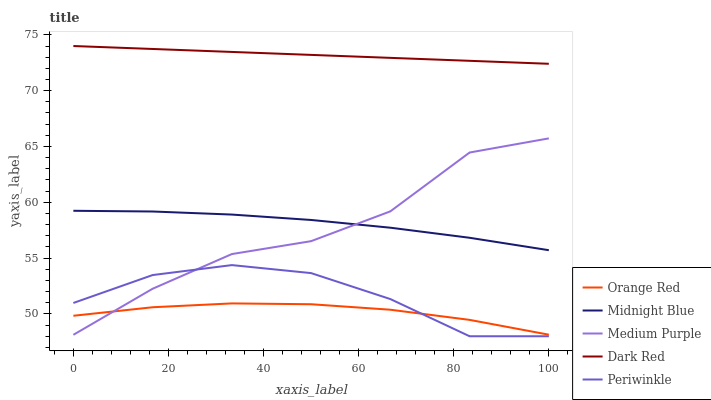Does Periwinkle have the minimum area under the curve?
Answer yes or no. No. Does Periwinkle have the maximum area under the curve?
Answer yes or no. No. Is Periwinkle the smoothest?
Answer yes or no. No. Is Periwinkle the roughest?
Answer yes or no. No. Does Dark Red have the lowest value?
Answer yes or no. No. Does Periwinkle have the highest value?
Answer yes or no. No. Is Orange Red less than Dark Red?
Answer yes or no. Yes. Is Dark Red greater than Medium Purple?
Answer yes or no. Yes. Does Orange Red intersect Dark Red?
Answer yes or no. No. 